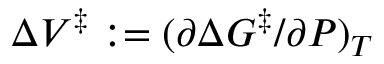Convert formula to latex. <formula><loc_0><loc_0><loc_500><loc_500>\Delta V ^ { \ddagger } \colon = ( \partial \Delta G ^ { \ddagger } / \partial P ) _ { T }</formula> 